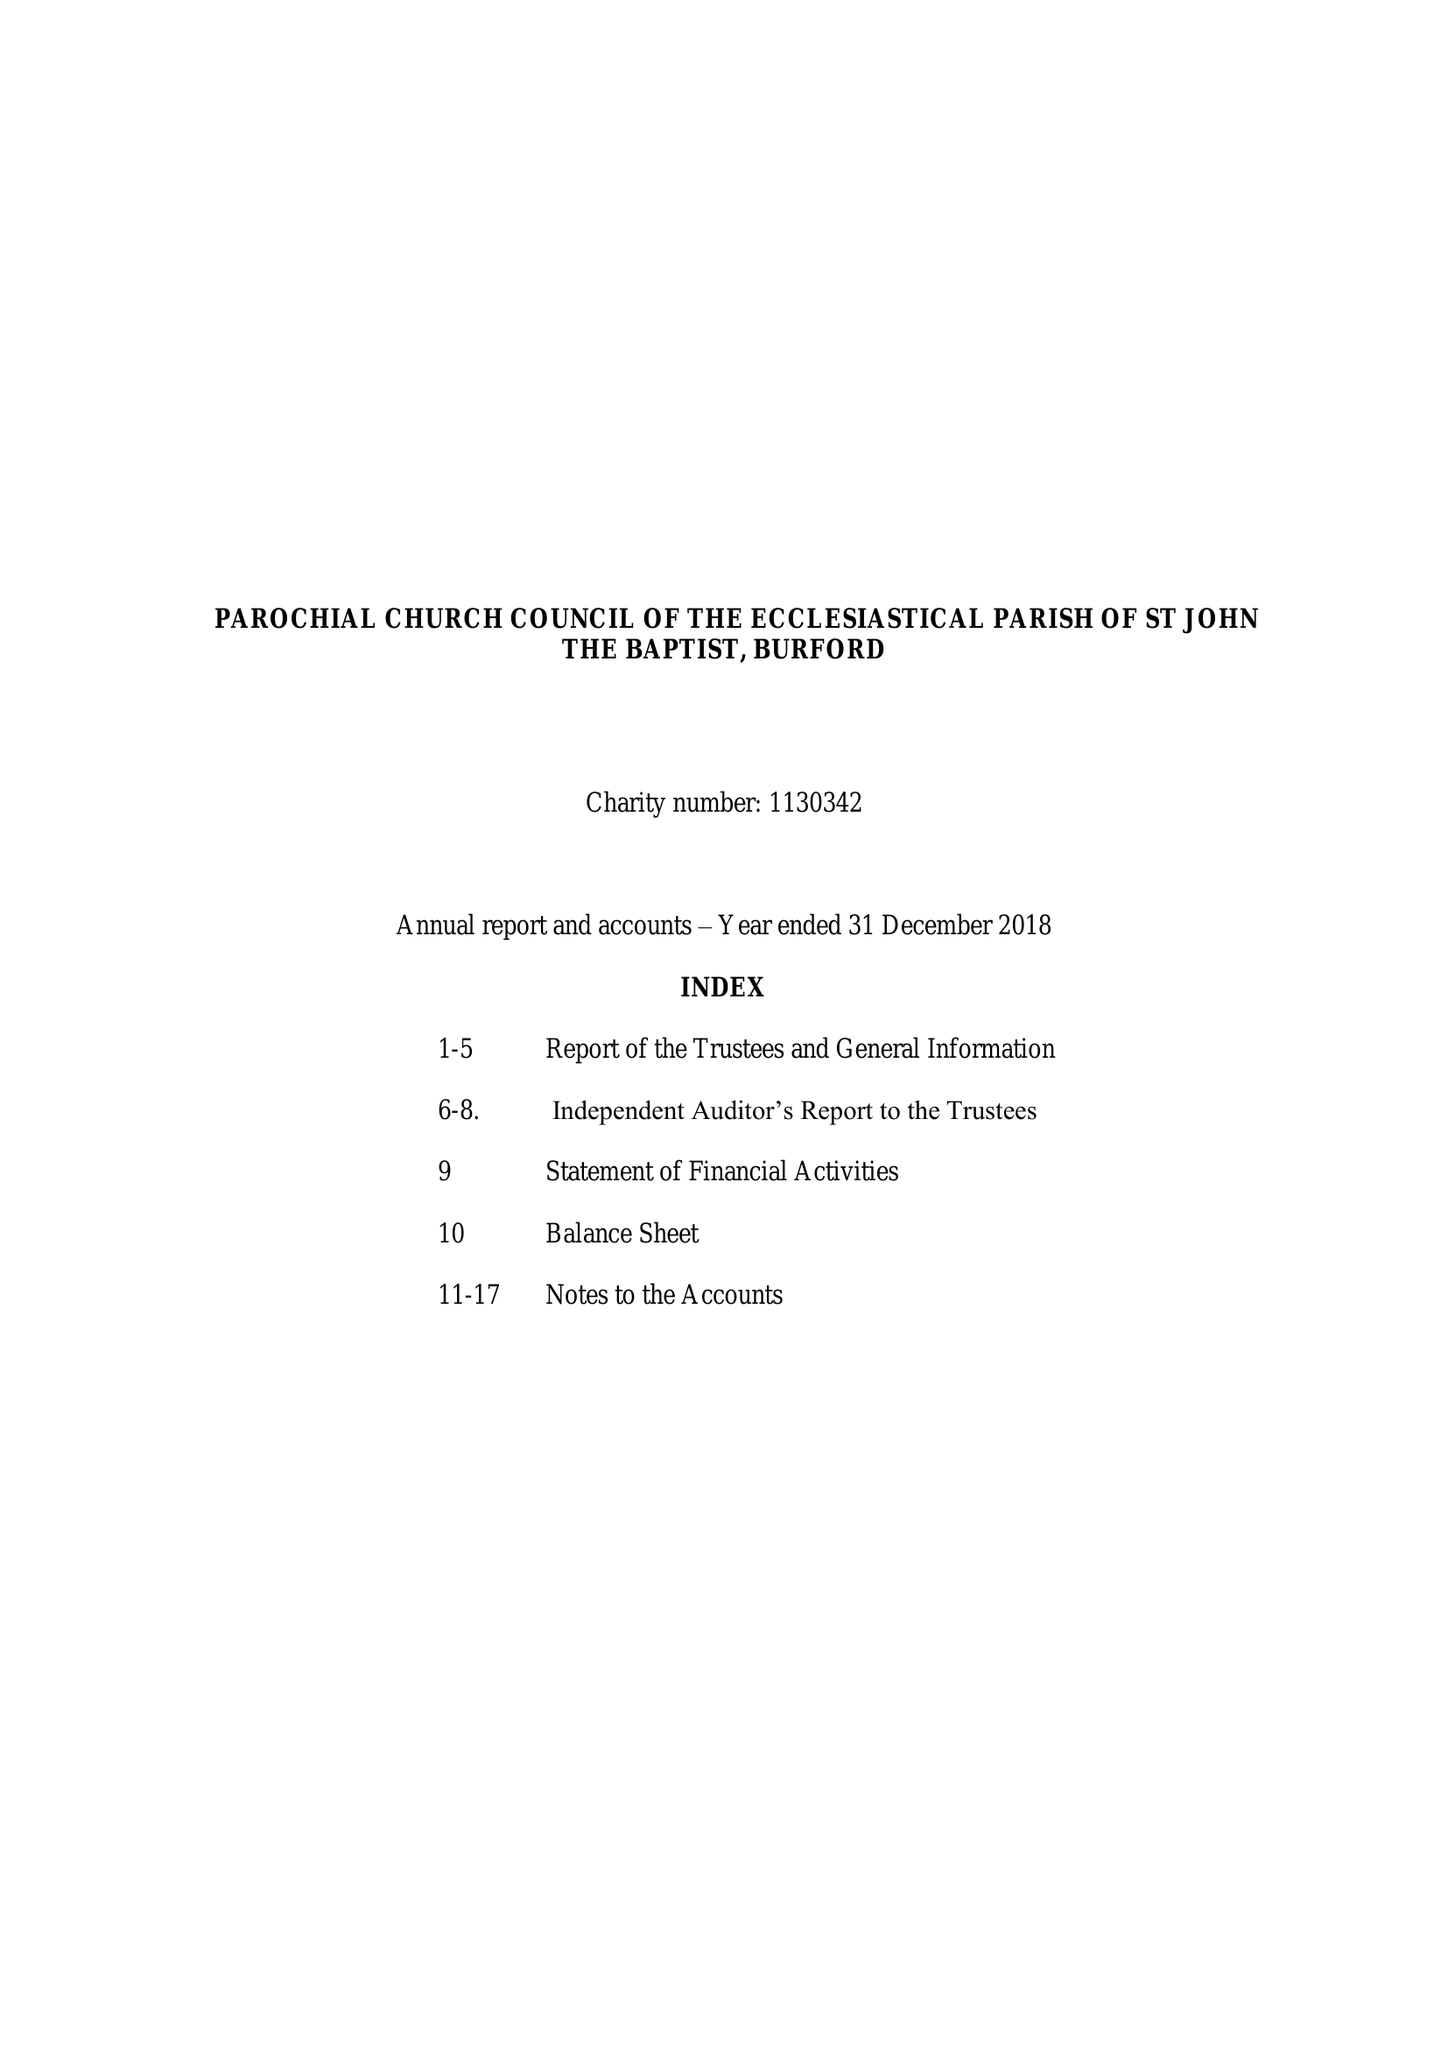What is the value for the charity_name?
Answer the question using a single word or phrase. The Parochial Church Council Of The Ecclesiastical Parish Of St John The Baptist, Burford 